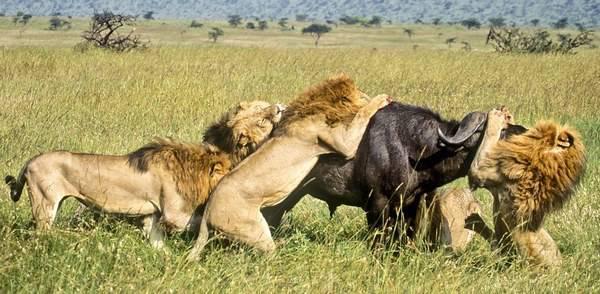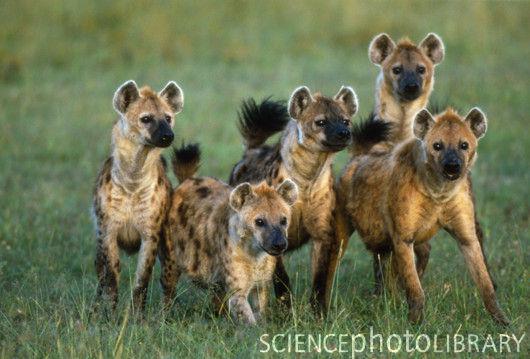The first image is the image on the left, the second image is the image on the right. For the images displayed, is the sentence "The image on the right shows no more than 5 cats." factually correct? Answer yes or no. Yes. The first image is the image on the left, the second image is the image on the right. Analyze the images presented: Is the assertion "There are at least three hyenas facing forward in the grass." valid? Answer yes or no. Yes. 